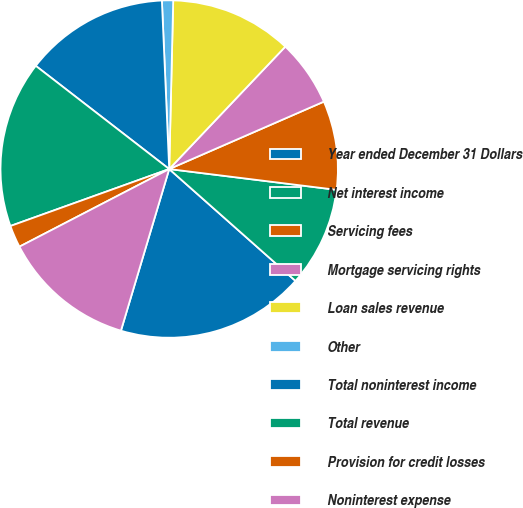Convert chart to OTSL. <chart><loc_0><loc_0><loc_500><loc_500><pie_chart><fcel>Year ended December 31 Dollars<fcel>Net interest income<fcel>Servicing fees<fcel>Mortgage servicing rights<fcel>Loan sales revenue<fcel>Other<fcel>Total noninterest income<fcel>Total revenue<fcel>Provision for credit losses<fcel>Noninterest expense<nl><fcel>18.08%<fcel>9.57%<fcel>8.51%<fcel>6.38%<fcel>11.7%<fcel>1.07%<fcel>13.83%<fcel>15.96%<fcel>2.13%<fcel>12.77%<nl></chart> 